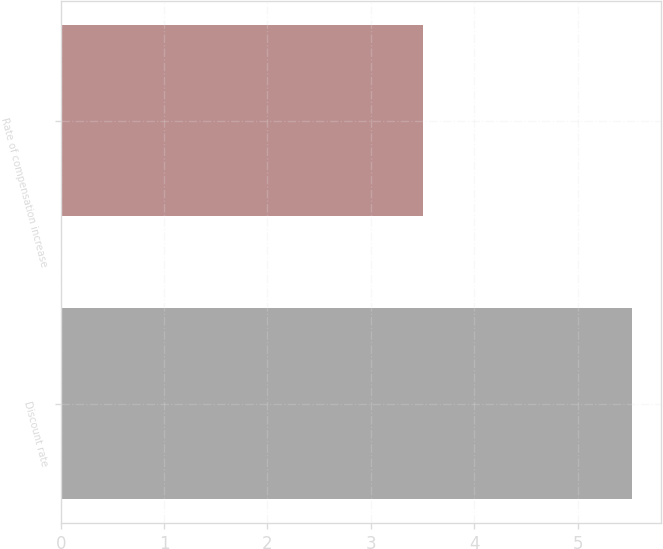Convert chart. <chart><loc_0><loc_0><loc_500><loc_500><bar_chart><fcel>Discount rate<fcel>Rate of compensation increase<nl><fcel>5.53<fcel>3.5<nl></chart> 